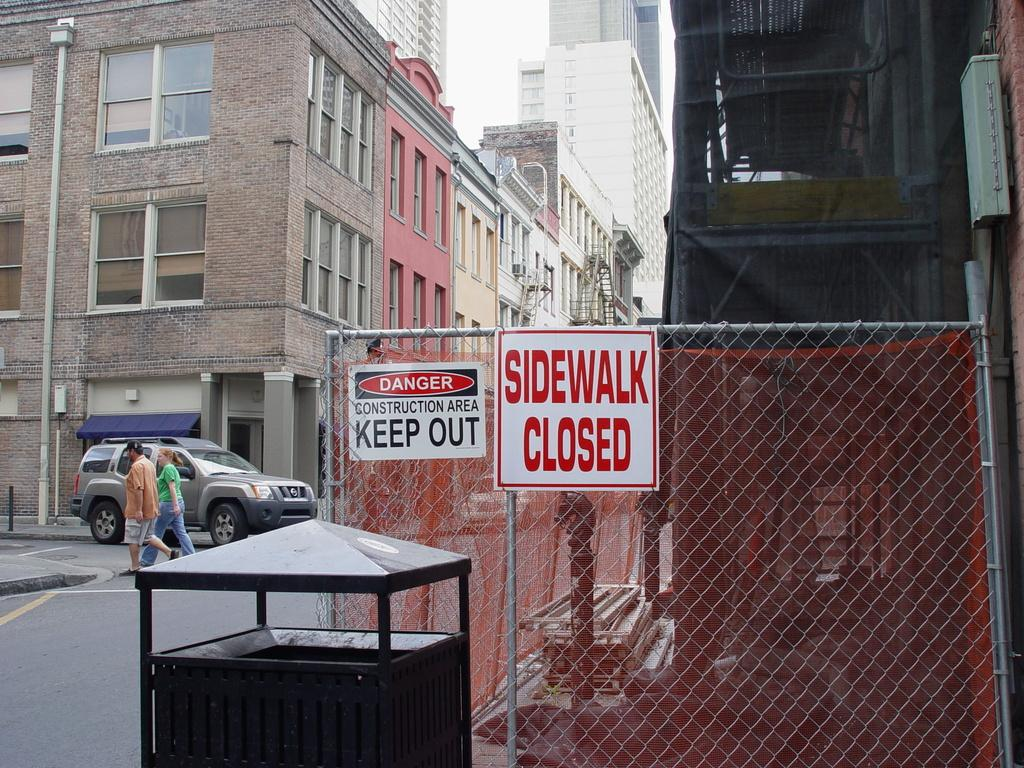What type of structures can be seen in the image? There are buildings in the image. What is happening on the road in the image? A vehicle is moving on the road in the image. Are there any people visible in the image? Yes, there are people walking in the image. What is separating the buildings from the road in the image? There is a fence in the image. What is attached to the fence in the image? Boards are attached to the fence in the image. Can you describe the battle taking place in the image? There is no battle present in the image; it features buildings, a moving vehicle, people walking, a fence, and boards attached to the fence. Are there any boats visible in the image? There are no boats present in the image. 